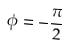<formula> <loc_0><loc_0><loc_500><loc_500>\phi = - \frac { \pi } { 2 }</formula> 